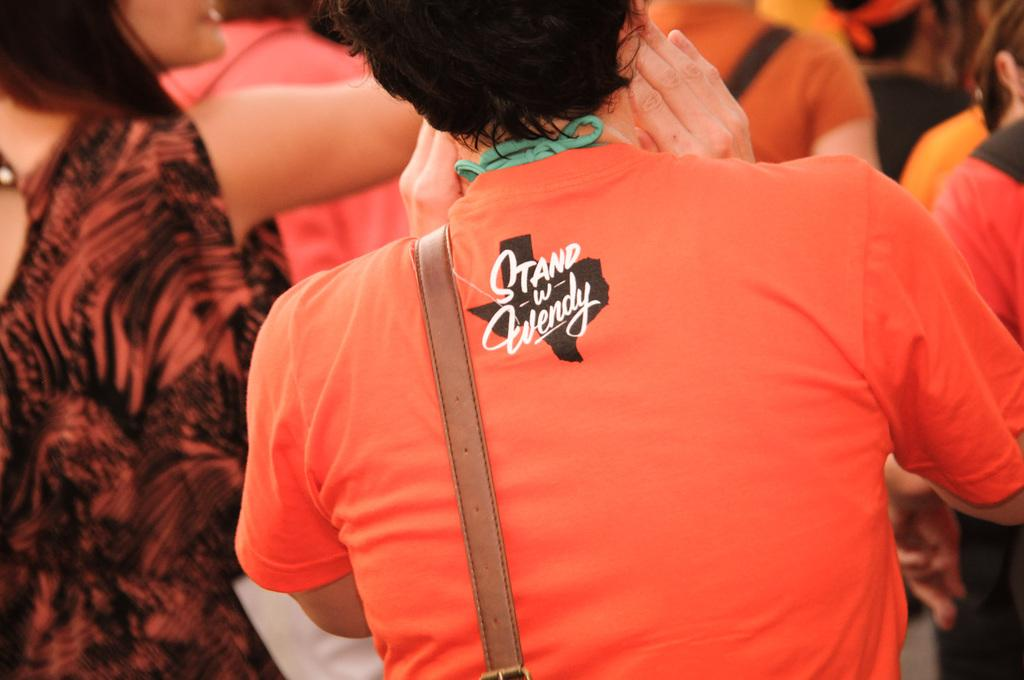How many people are in the image? There are people in the image, but the exact number is not specified. Can you describe any specific features of the people in the image? One person is wearing a strap. How many potatoes are being held by the daughter in the image? There is no daughter or potatoes present in the image. What type of tomatoes can be seen growing in the background of the image? There is no mention of tomatoes or a background in the provided facts. 